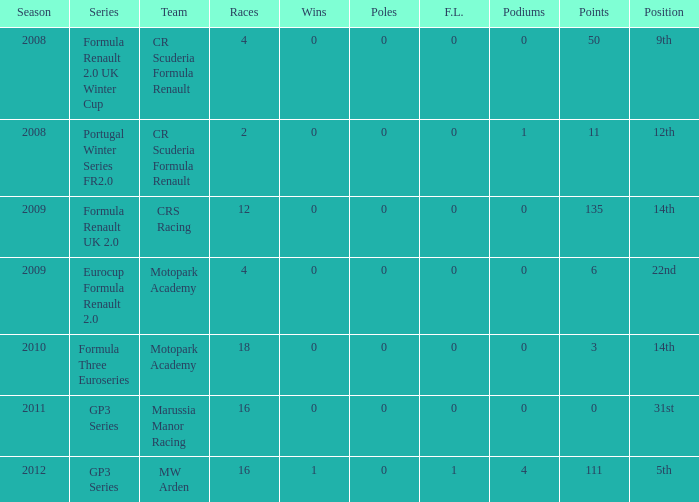How many F.L. are listed for Formula Three Euroseries? 1.0. 